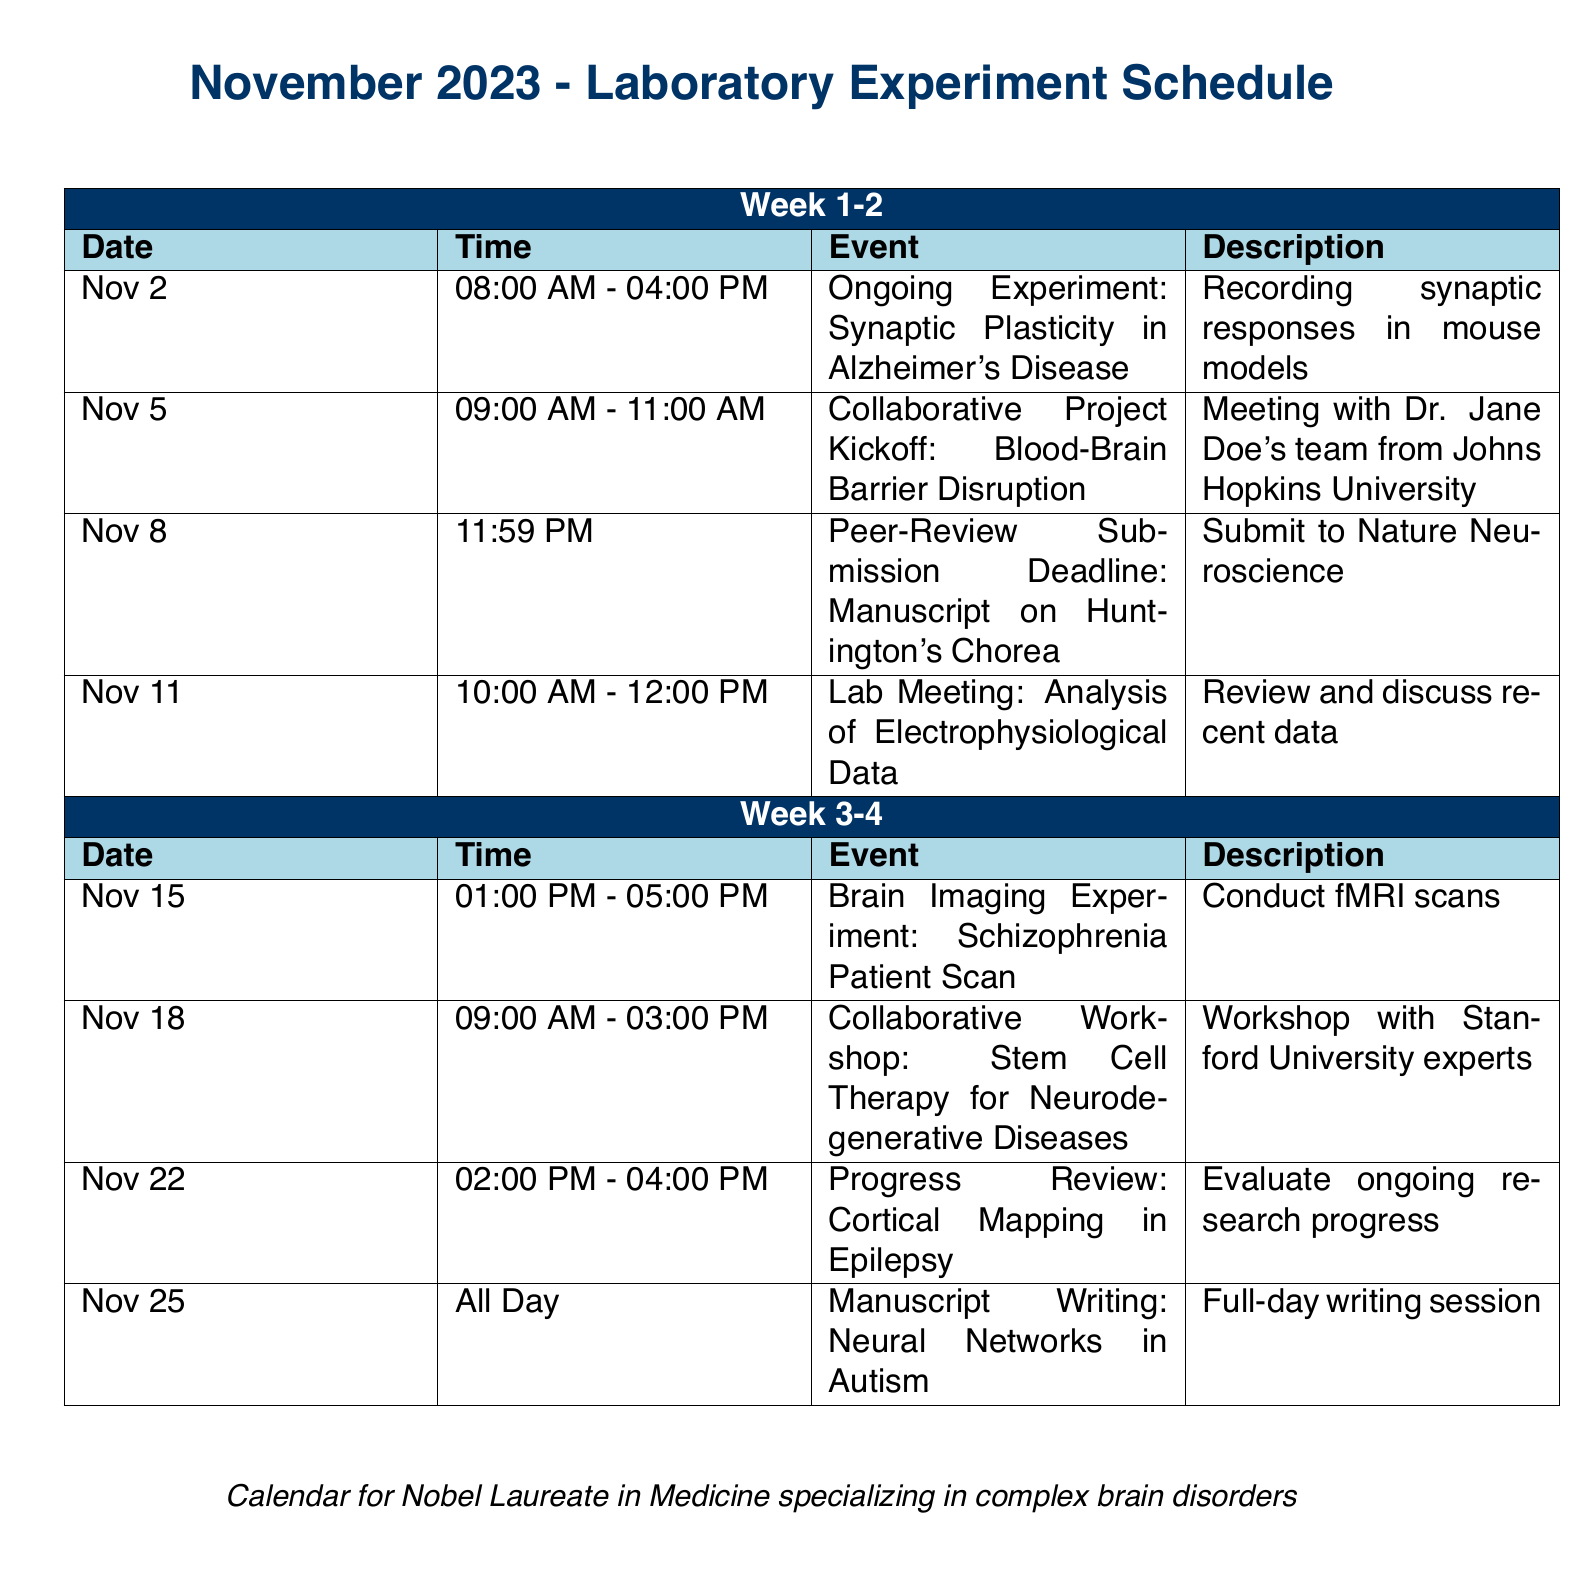What is the date of the peer-review submission deadline? The deadline is explicitly stated in the schedule as November 8.
Answer: November 8 What time is the ongoing experiment on November 2? The time range for the ongoing experiment is provided in the document.
Answer: 08:00 AM - 04:00 PM Who is collaborating with the laboratory on the Blood-Brain Barrier Disruption project? The document mentions Dr. Jane Doe from Johns Hopkins University for the collaboration.
Answer: Dr. Jane Doe What type of experiment is scheduled for November 15? The event scheduled is a brain imaging experiment, as noted in the schedule.
Answer: Brain Imaging Experiment: Schizophrenia Patient Scan How long is the collaborative workshop on November 18? The document specifies the duration of the workshop from 9:00 AM to 3:00 PM.
Answer: 6 hours What is the focus of the manuscript being written on November 25? The topic of the manuscript is described in the schedule.
Answer: Neural Networks in Autism How many events are scheduled in Week 3-4? The schedule outlines three distinct events within that timeframe.
Answer: 4 events At what time does the lab meeting on November 11 start? The lab meeting time is listed as starting at 10:00 AM.
Answer: 10:00 AM When is the progress review on cortical mapping in epilepsy? The specific date for the progress review is provided in the calendar.
Answer: November 22 